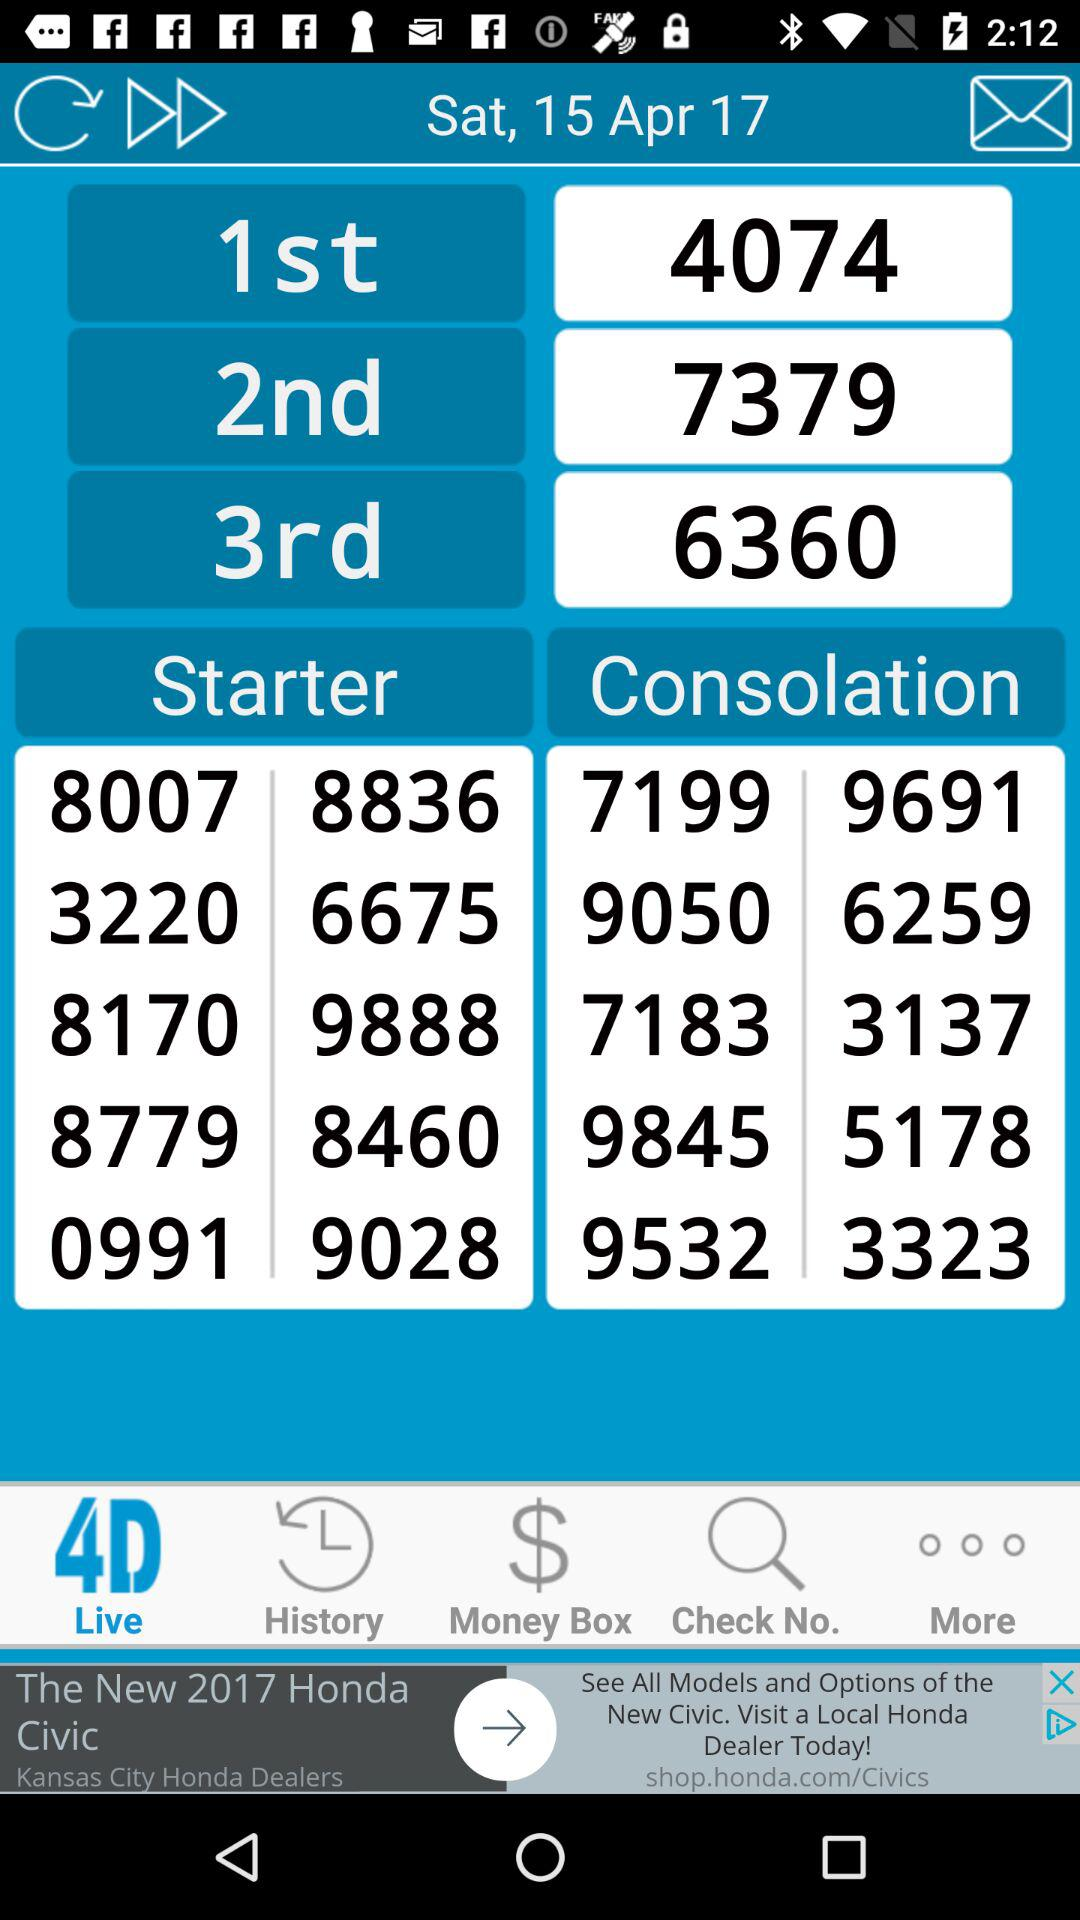Which tab am I using? You are using the "Live" tab. 